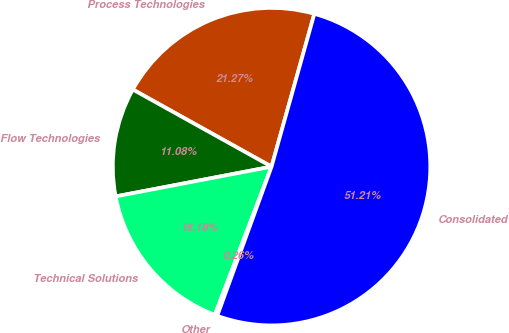Convert chart to OTSL. <chart><loc_0><loc_0><loc_500><loc_500><pie_chart><fcel>Process Technologies<fcel>Flow Technologies<fcel>Technical Solutions<fcel>Other<fcel>Consolidated<nl><fcel>21.27%<fcel>11.08%<fcel>16.18%<fcel>0.26%<fcel>51.21%<nl></chart> 